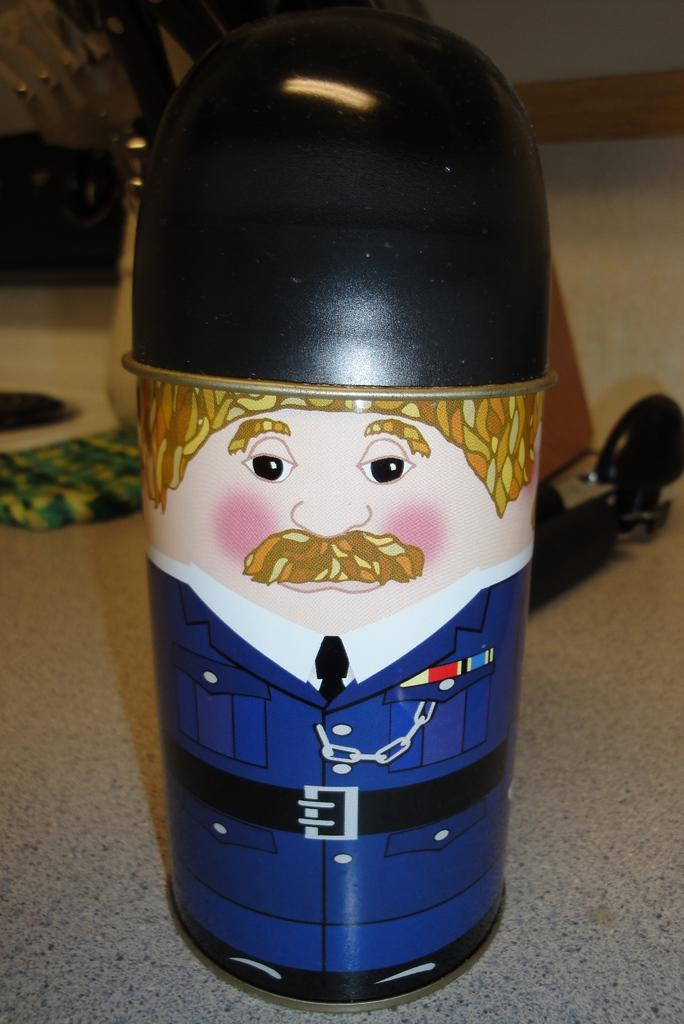What type of toy is in the image? There is a toy person in the image. What is the toy person wearing? The toy person is wearing a blue dress. What can be seen on the floor in the background of the image? There are objects on the floor in the background of the image. What color is the wall in the background of the image? The wall in the background is white. What type of disease is affecting the toy person in the image? There is no indication of any disease affecting the toy person in the image. Can you tell me how many bananas are on the floor in the image? There are no bananas present in the image. 